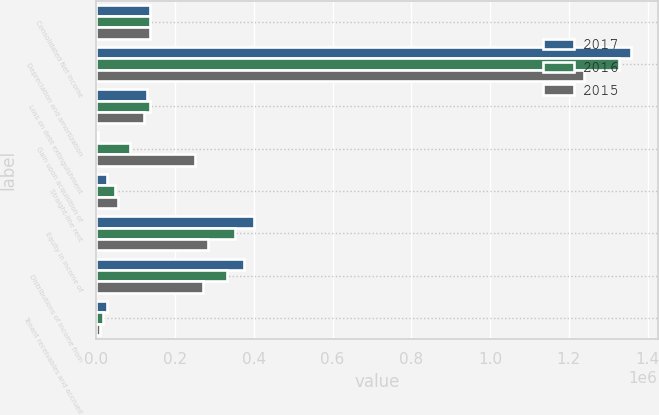Convert chart. <chart><loc_0><loc_0><loc_500><loc_500><stacked_bar_chart><ecel><fcel>Consolidated Net Income<fcel>Depreciation and amortization<fcel>Loss on debt extinguishment<fcel>Gain upon acquisition of<fcel>Straight-line rent<fcel>Equity in income of<fcel>Distributions of income from<fcel>Tenant receivables and accrued<nl><fcel>2017<fcel>136777<fcel>1.35735e+06<fcel>128618<fcel>3647<fcel>26543<fcel>400270<fcel>374101<fcel>26170<nl><fcel>2016<fcel>136777<fcel>1.32795e+06<fcel>136777<fcel>84553<fcel>46656<fcel>353334<fcel>331627<fcel>16277<nl><fcel>2015<fcel>136777<fcel>1.23921e+06<fcel>120953<fcel>250516<fcel>54129<fcel>284806<fcel>271998<fcel>9918<nl></chart> 